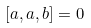<formula> <loc_0><loc_0><loc_500><loc_500>[ a , a , b ] = 0</formula> 